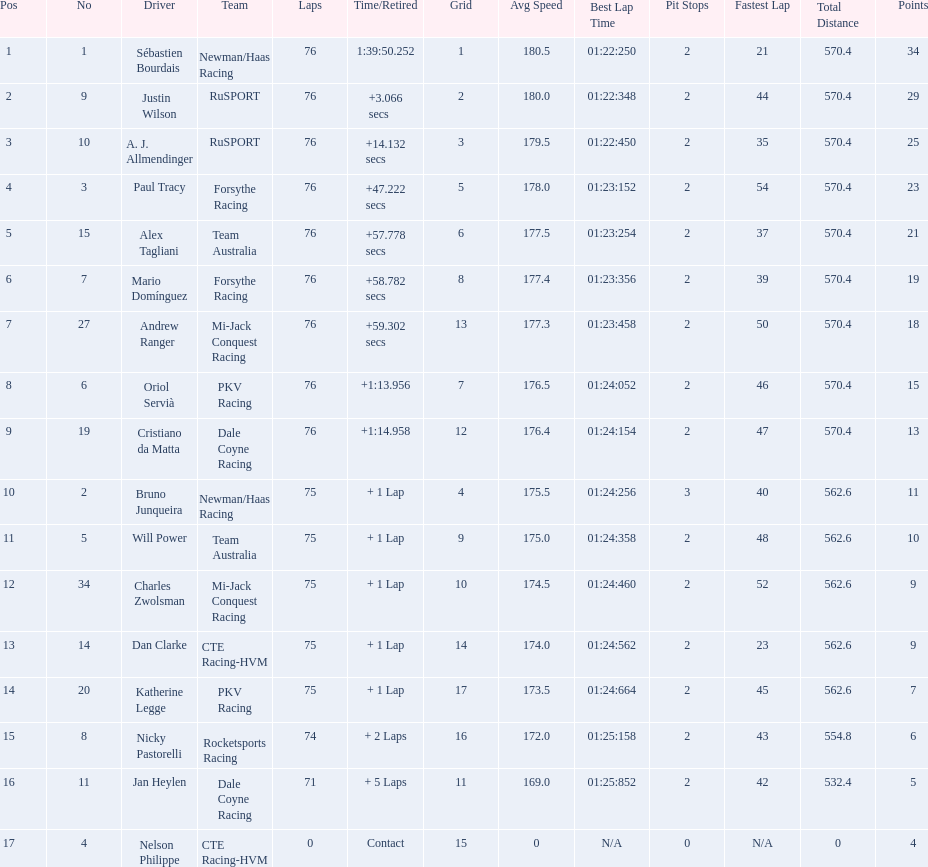What was alex taglini's final score in the tecate grand prix? 21. What was paul tracy's final score in the tecate grand prix? 23. Which driver finished first? Paul Tracy. 